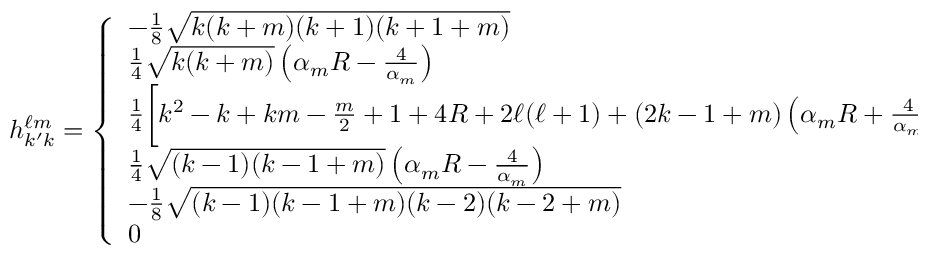Convert formula to latex. <formula><loc_0><loc_0><loc_500><loc_500>h _ { k ^ { \prime } k } ^ { \ell m } = \left \{ \begin{array} { l l } { - \frac { 1 } { 8 } \sqrt { k ( k + m ) ( k + 1 ) ( k + 1 + m ) } } & { k ^ { \prime } = k + 2 , } \\ { \frac { 1 } { 4 } \sqrt { k ( k + m ) } \left ( \alpha _ { m } R - \frac { 4 } { \alpha _ { m } } \right ) } & { k ^ { \prime } = k + 1 , } \\ { \frac { 1 } { 4 } \left [ k ^ { 2 } - k + k m - \frac { m } { 2 } + 1 + 4 R + 2 \ell ( \ell + 1 ) + ( 2 k - 1 + m ) \left ( \alpha _ { m } R + \frac { 4 } { \alpha _ { m } } \right ) \right ] } & { k ^ { \prime } = k , } \\ { \frac { 1 } { 4 } \sqrt { ( k - 1 ) ( k - 1 + m ) } \left ( \alpha _ { m } R - \frac { 4 } { \alpha _ { m } } \right ) } & { k ^ { \prime } = k - 1 , } \\ { - \frac { 1 } { 8 } \sqrt { ( k - 1 ) ( k - 1 + m ) ( k - 2 ) ( k - 2 + m ) } } & { k ^ { \prime } = k - 2 , } \\ { 0 } & { o t h e r w i s e , } \end{array}</formula> 